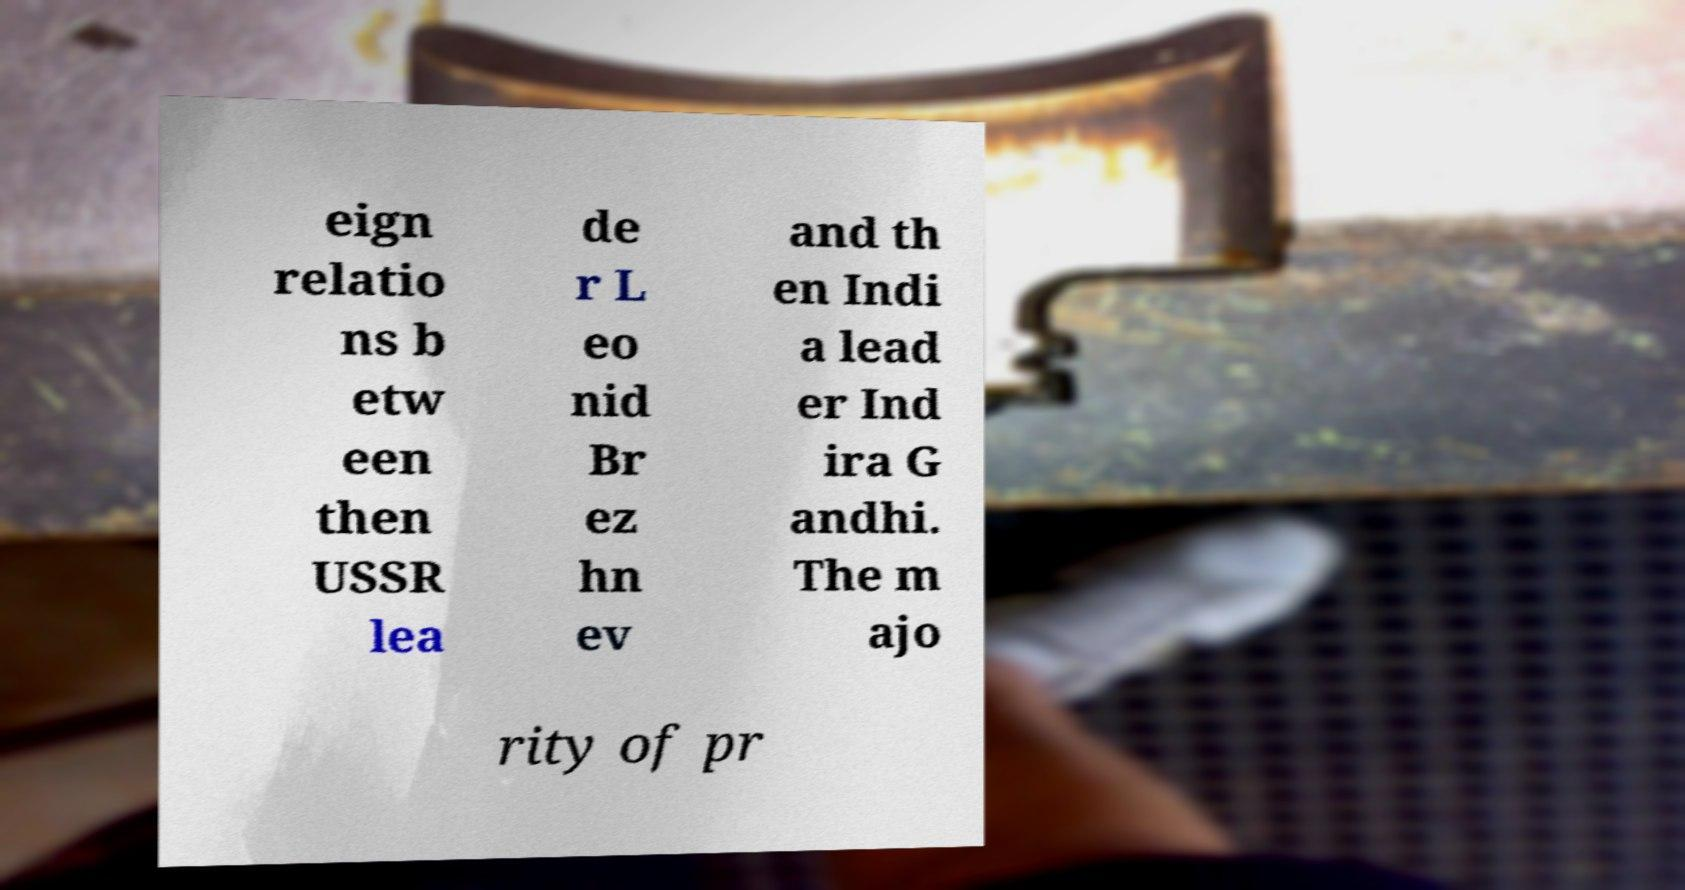Can you accurately transcribe the text from the provided image for me? eign relatio ns b etw een then USSR lea de r L eo nid Br ez hn ev and th en Indi a lead er Ind ira G andhi. The m ajo rity of pr 